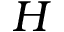<formula> <loc_0><loc_0><loc_500><loc_500>H</formula> 